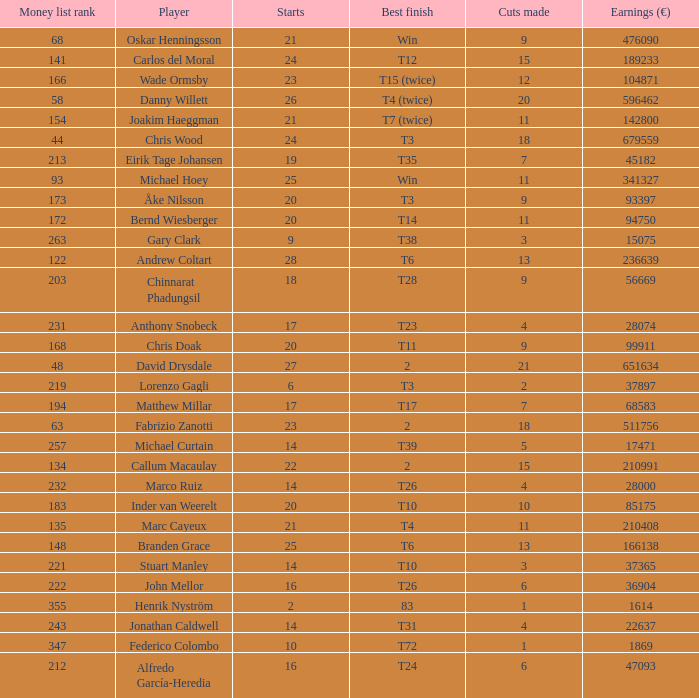Parse the full table. {'header': ['Money list rank', 'Player', 'Starts', 'Best finish', 'Cuts made', 'Earnings (€)'], 'rows': [['68', 'Oskar Henningsson', '21', 'Win', '9', '476090'], ['141', 'Carlos del Moral', '24', 'T12', '15', '189233'], ['166', 'Wade Ormsby', '23', 'T15 (twice)', '12', '104871'], ['58', 'Danny Willett', '26', 'T4 (twice)', '20', '596462'], ['154', 'Joakim Haeggman', '21', 'T7 (twice)', '11', '142800'], ['44', 'Chris Wood', '24', 'T3', '18', '679559'], ['213', 'Eirik Tage Johansen', '19', 'T35', '7', '45182'], ['93', 'Michael Hoey', '25', 'Win', '11', '341327'], ['173', 'Åke Nilsson', '20', 'T3', '9', '93397'], ['172', 'Bernd Wiesberger', '20', 'T14', '11', '94750'], ['263', 'Gary Clark', '9', 'T38', '3', '15075'], ['122', 'Andrew Coltart', '28', 'T6', '13', '236639'], ['203', 'Chinnarat Phadungsil', '18', 'T28', '9', '56669'], ['231', 'Anthony Snobeck', '17', 'T23', '4', '28074'], ['168', 'Chris Doak', '20', 'T11', '9', '99911'], ['48', 'David Drysdale', '27', '2', '21', '651634'], ['219', 'Lorenzo Gagli', '6', 'T3', '2', '37897'], ['194', 'Matthew Millar', '17', 'T17', '7', '68583'], ['63', 'Fabrizio Zanotti', '23', '2', '18', '511756'], ['257', 'Michael Curtain', '14', 'T39', '5', '17471'], ['134', 'Callum Macaulay', '22', '2', '15', '210991'], ['232', 'Marco Ruiz', '14', 'T26', '4', '28000'], ['183', 'Inder van Weerelt', '20', 'T10', '10', '85175'], ['135', 'Marc Cayeux', '21', 'T4', '11', '210408'], ['148', 'Branden Grace', '25', 'T6', '13', '166138'], ['221', 'Stuart Manley', '14', 'T10', '3', '37365'], ['222', 'John Mellor', '16', 'T26', '6', '36904'], ['355', 'Henrik Nyström', '2', '83', '1', '1614'], ['243', 'Jonathan Caldwell', '14', 'T31', '4', '22637'], ['347', 'Federico Colombo', '10', 'T72', '1', '1869'], ['212', 'Alfredo García-Heredia', '16', 'T24', '6', '47093']]} Which player made exactly 26 starts? Danny Willett. 